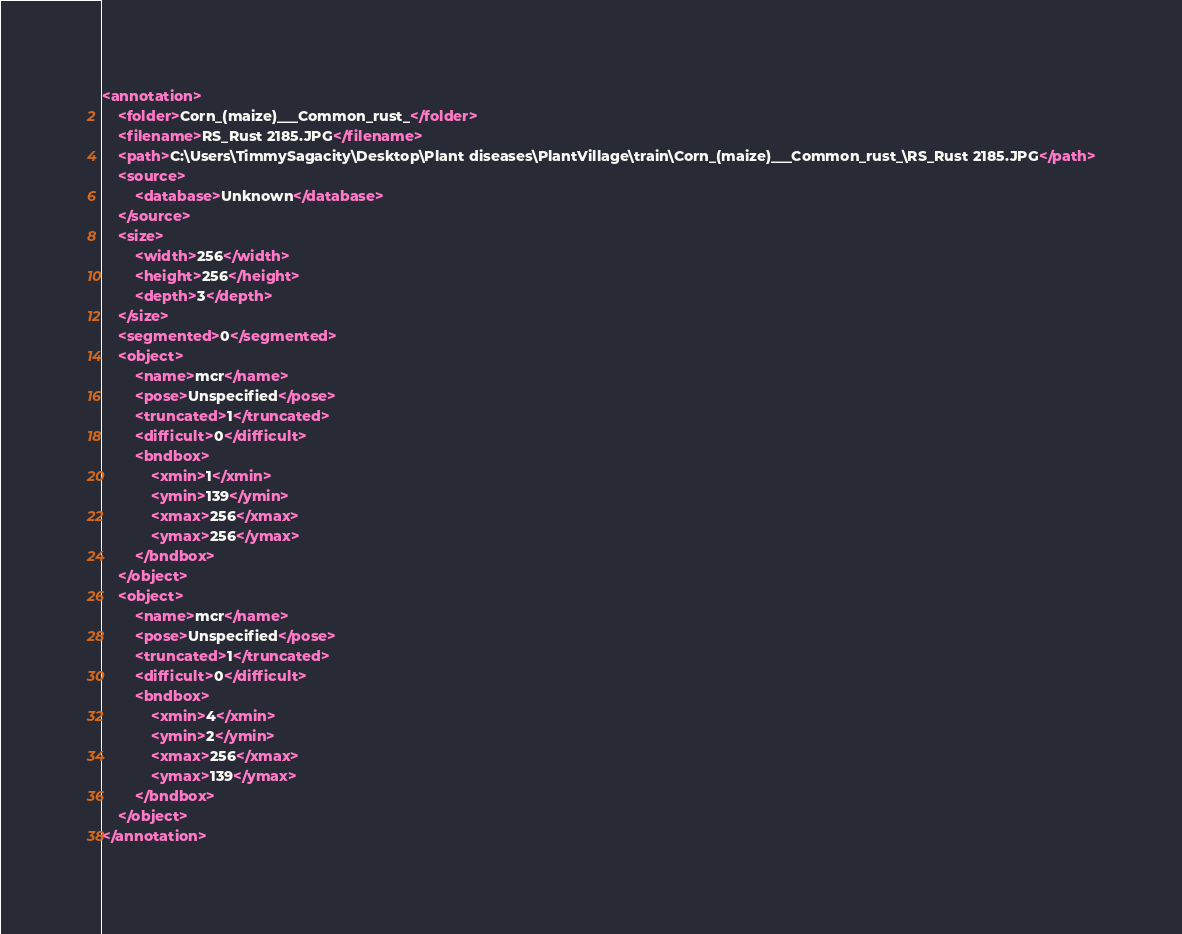Convert code to text. <code><loc_0><loc_0><loc_500><loc_500><_XML_><annotation>
	<folder>Corn_(maize)___Common_rust_</folder>
	<filename>RS_Rust 2185.JPG</filename>
	<path>C:\Users\TimmySagacity\Desktop\Plant diseases\PlantVillage\train\Corn_(maize)___Common_rust_\RS_Rust 2185.JPG</path>
	<source>
		<database>Unknown</database>
	</source>
	<size>
		<width>256</width>
		<height>256</height>
		<depth>3</depth>
	</size>
	<segmented>0</segmented>
	<object>
		<name>mcr</name>
		<pose>Unspecified</pose>
		<truncated>1</truncated>
		<difficult>0</difficult>
		<bndbox>
			<xmin>1</xmin>
			<ymin>139</ymin>
			<xmax>256</xmax>
			<ymax>256</ymax>
		</bndbox>
	</object>
	<object>
		<name>mcr</name>
		<pose>Unspecified</pose>
		<truncated>1</truncated>
		<difficult>0</difficult>
		<bndbox>
			<xmin>4</xmin>
			<ymin>2</ymin>
			<xmax>256</xmax>
			<ymax>139</ymax>
		</bndbox>
	</object>
</annotation>
</code> 